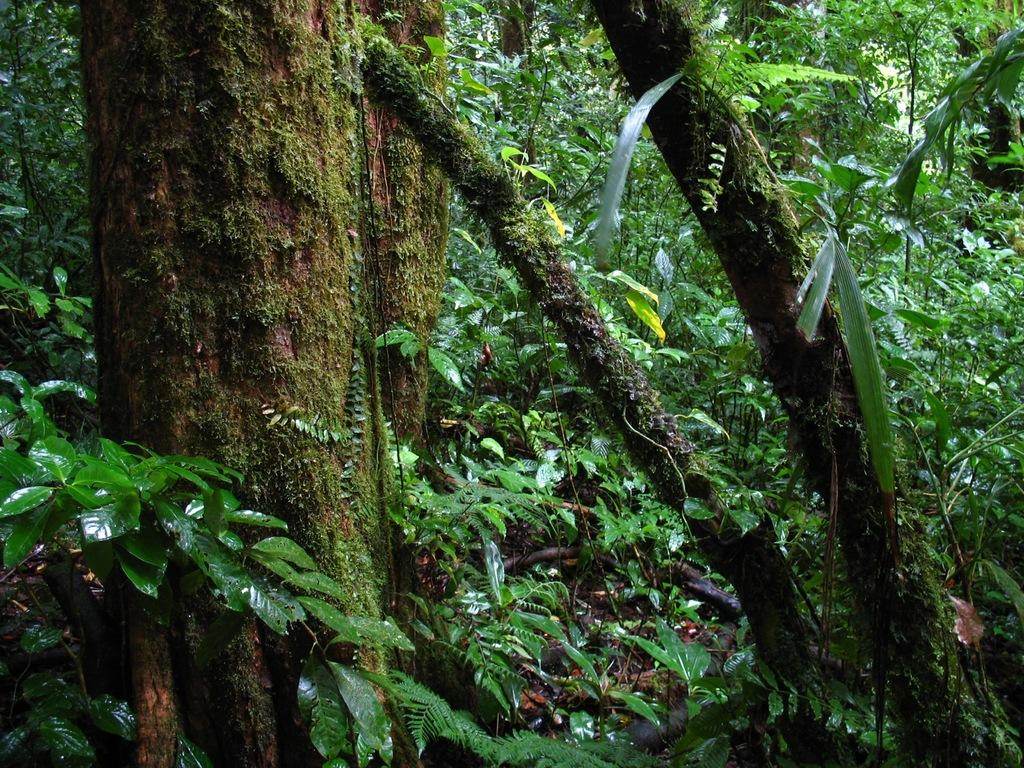What type of vegetation can be seen in the image? There are trees in the image. What type of cake is being served under the veil in the image? There is no cake or veil present in the image; it only features trees. 